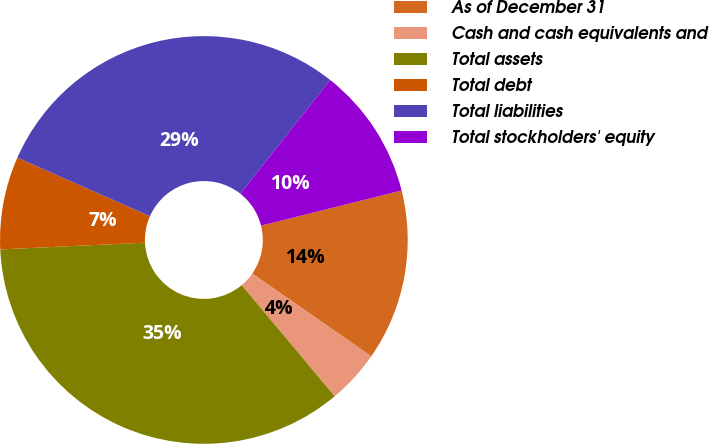Convert chart. <chart><loc_0><loc_0><loc_500><loc_500><pie_chart><fcel>As of December 31<fcel>Cash and cash equivalents and<fcel>Total assets<fcel>Total debt<fcel>Total liabilities<fcel>Total stockholders' equity<nl><fcel>13.57%<fcel>4.24%<fcel>35.35%<fcel>7.35%<fcel>29.02%<fcel>10.46%<nl></chart> 